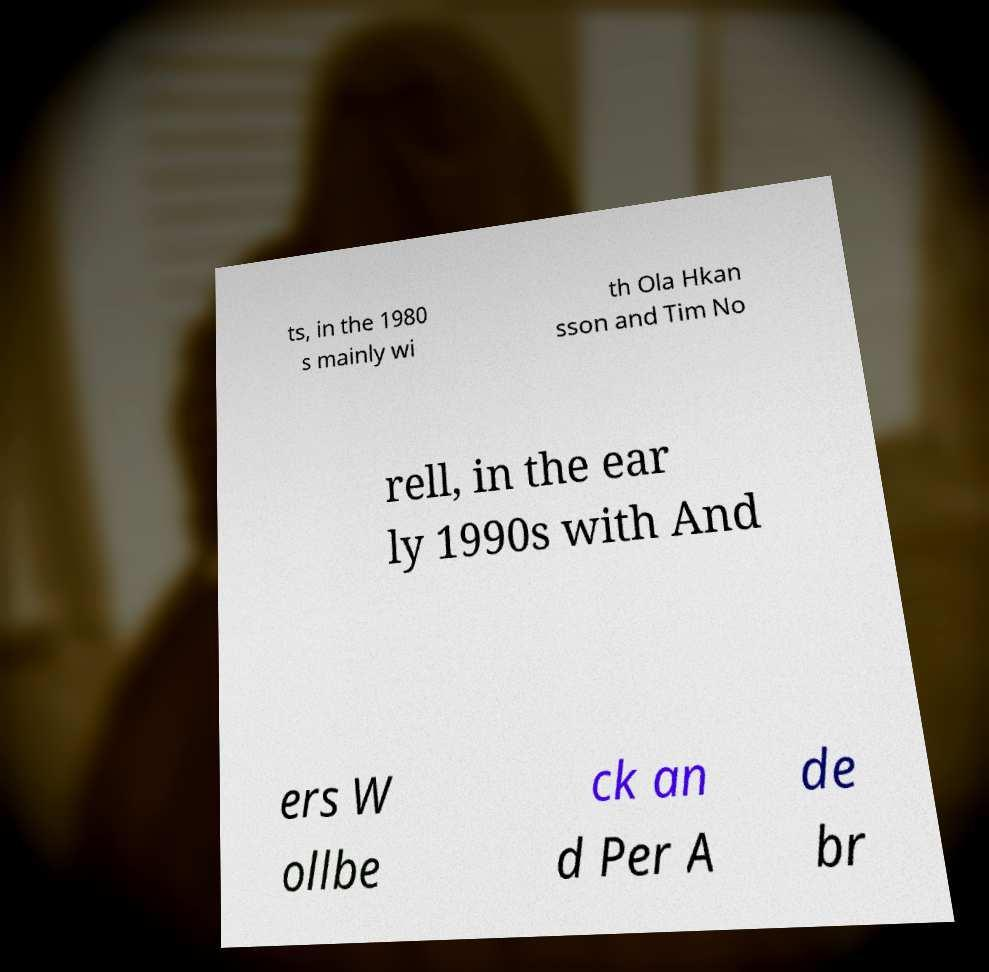Could you extract and type out the text from this image? ts, in the 1980 s mainly wi th Ola Hkan sson and Tim No rell, in the ear ly 1990s with And ers W ollbe ck an d Per A de br 